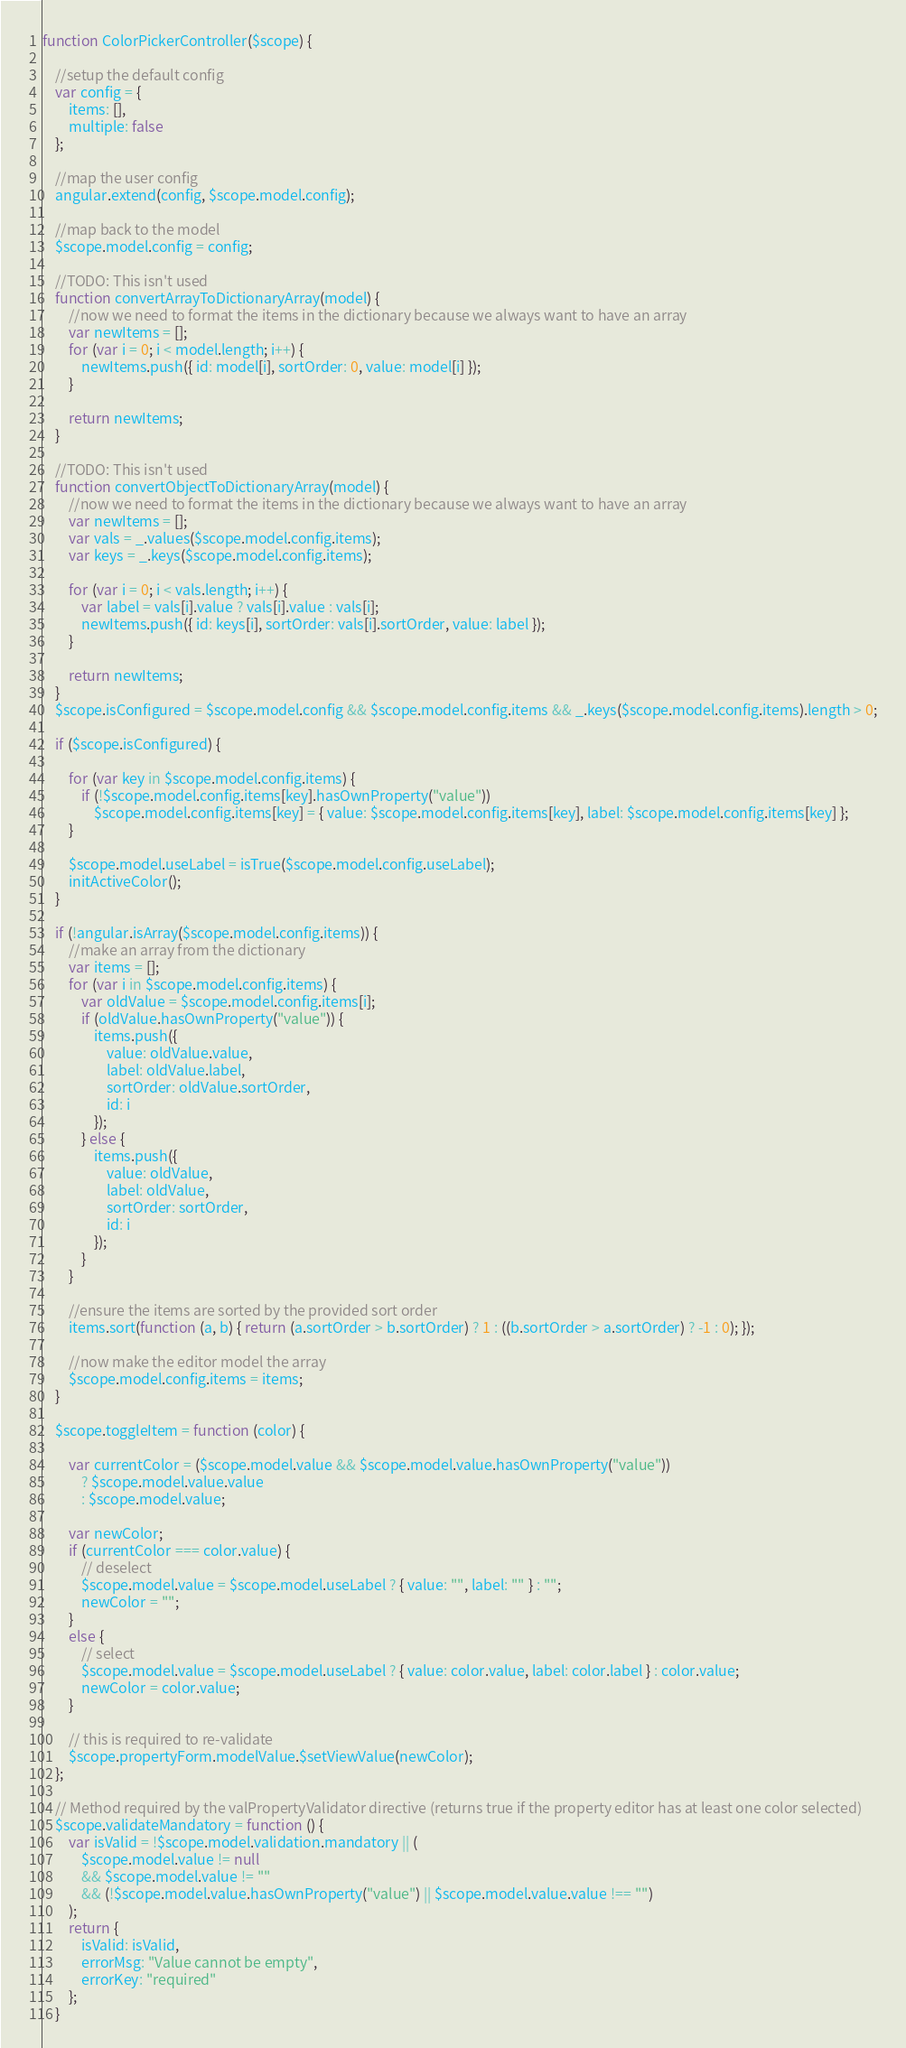Convert code to text. <code><loc_0><loc_0><loc_500><loc_500><_JavaScript_>function ColorPickerController($scope) {

    //setup the default config
    var config = {
        items: [],
        multiple: false
    };
    
    //map the user config
    angular.extend(config, $scope.model.config);

    //map back to the model
    $scope.model.config = config;

    //TODO: This isn't used
    function convertArrayToDictionaryArray(model) {
        //now we need to format the items in the dictionary because we always want to have an array
        var newItems = [];
        for (var i = 0; i < model.length; i++) {
            newItems.push({ id: model[i], sortOrder: 0, value: model[i] });
        }

        return newItems;
    }

    //TODO: This isn't used
    function convertObjectToDictionaryArray(model) {
        //now we need to format the items in the dictionary because we always want to have an array
        var newItems = [];
        var vals = _.values($scope.model.config.items);
        var keys = _.keys($scope.model.config.items);

        for (var i = 0; i < vals.length; i++) {
            var label = vals[i].value ? vals[i].value : vals[i];
            newItems.push({ id: keys[i], sortOrder: vals[i].sortOrder, value: label });
        }

        return newItems;
    }
    $scope.isConfigured = $scope.model.config && $scope.model.config.items && _.keys($scope.model.config.items).length > 0;

    if ($scope.isConfigured) {

        for (var key in $scope.model.config.items) {
            if (!$scope.model.config.items[key].hasOwnProperty("value"))
                $scope.model.config.items[key] = { value: $scope.model.config.items[key], label: $scope.model.config.items[key] };
        }

        $scope.model.useLabel = isTrue($scope.model.config.useLabel);
        initActiveColor();
    }

    if (!angular.isArray($scope.model.config.items)) {
        //make an array from the dictionary
        var items = [];
        for (var i in $scope.model.config.items) {
            var oldValue = $scope.model.config.items[i];
            if (oldValue.hasOwnProperty("value")) {
                items.push({
                    value: oldValue.value,
                    label: oldValue.label,
                    sortOrder: oldValue.sortOrder,
                    id: i
                });
            } else {
                items.push({
                    value: oldValue,
                    label: oldValue,
                    sortOrder: sortOrder,
                    id: i
                });
            }
        }

        //ensure the items are sorted by the provided sort order
        items.sort(function (a, b) { return (a.sortOrder > b.sortOrder) ? 1 : ((b.sortOrder > a.sortOrder) ? -1 : 0); });

        //now make the editor model the array
        $scope.model.config.items = items;
    }

    $scope.toggleItem = function (color) {

        var currentColor = ($scope.model.value && $scope.model.value.hasOwnProperty("value"))
            ? $scope.model.value.value
            : $scope.model.value;

        var newColor;
        if (currentColor === color.value) {
            // deselect
            $scope.model.value = $scope.model.useLabel ? { value: "", label: "" } : "";
            newColor = "";
        }
        else {
            // select
            $scope.model.value = $scope.model.useLabel ? { value: color.value, label: color.label } : color.value;
            newColor = color.value;
        }

        // this is required to re-validate
        $scope.propertyForm.modelValue.$setViewValue(newColor);
    };

    // Method required by the valPropertyValidator directive (returns true if the property editor has at least one color selected)
    $scope.validateMandatory = function () {
        var isValid = !$scope.model.validation.mandatory || (
            $scope.model.value != null
            && $scope.model.value != ""
            && (!$scope.model.value.hasOwnProperty("value") || $scope.model.value.value !== "")
        );
        return {
            isValid: isValid,
            errorMsg: "Value cannot be empty",
            errorKey: "required"
        };
    }</code> 